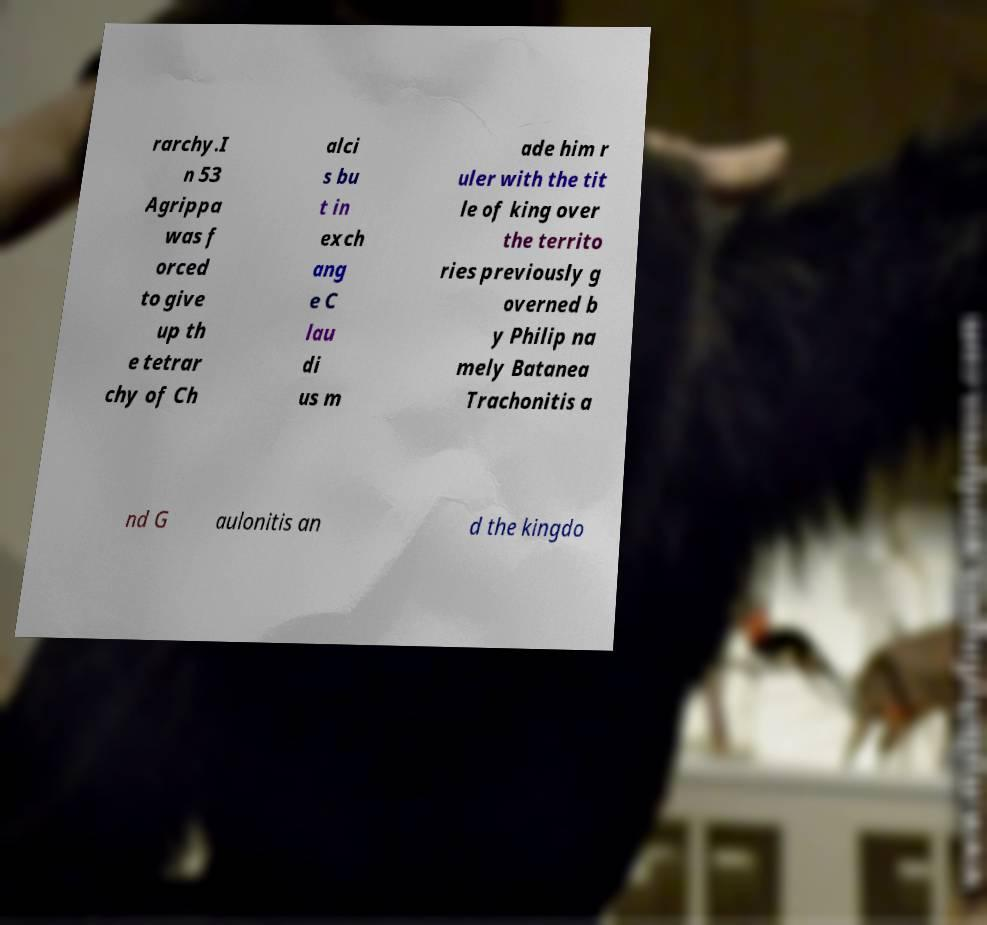For documentation purposes, I need the text within this image transcribed. Could you provide that? rarchy.I n 53 Agrippa was f orced to give up th e tetrar chy of Ch alci s bu t in exch ang e C lau di us m ade him r uler with the tit le of king over the territo ries previously g overned b y Philip na mely Batanea Trachonitis a nd G aulonitis an d the kingdo 